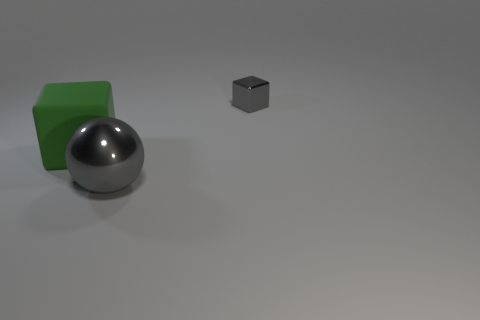Is there a green block behind the cube that is behind the big block?
Give a very brief answer. No. There is a cube that is the same material as the big gray thing; what color is it?
Give a very brief answer. Gray. Are there any yellow metal things that have the same size as the gray metal ball?
Your answer should be compact. No. Are there fewer yellow rubber cylinders than gray metallic objects?
Provide a short and direct response. Yes. What number of spheres are either red rubber things or big gray objects?
Ensure brevity in your answer.  1. What number of cubes are the same color as the large metallic ball?
Keep it short and to the point. 1. How big is the object that is to the right of the green matte cube and in front of the tiny gray cube?
Your response must be concise. Large. Are there fewer big objects that are right of the small gray metallic object than metallic spheres?
Give a very brief answer. Yes. Are the large green block and the tiny gray cube made of the same material?
Provide a short and direct response. No. What number of things are small red cylinders or blocks?
Keep it short and to the point. 2. 